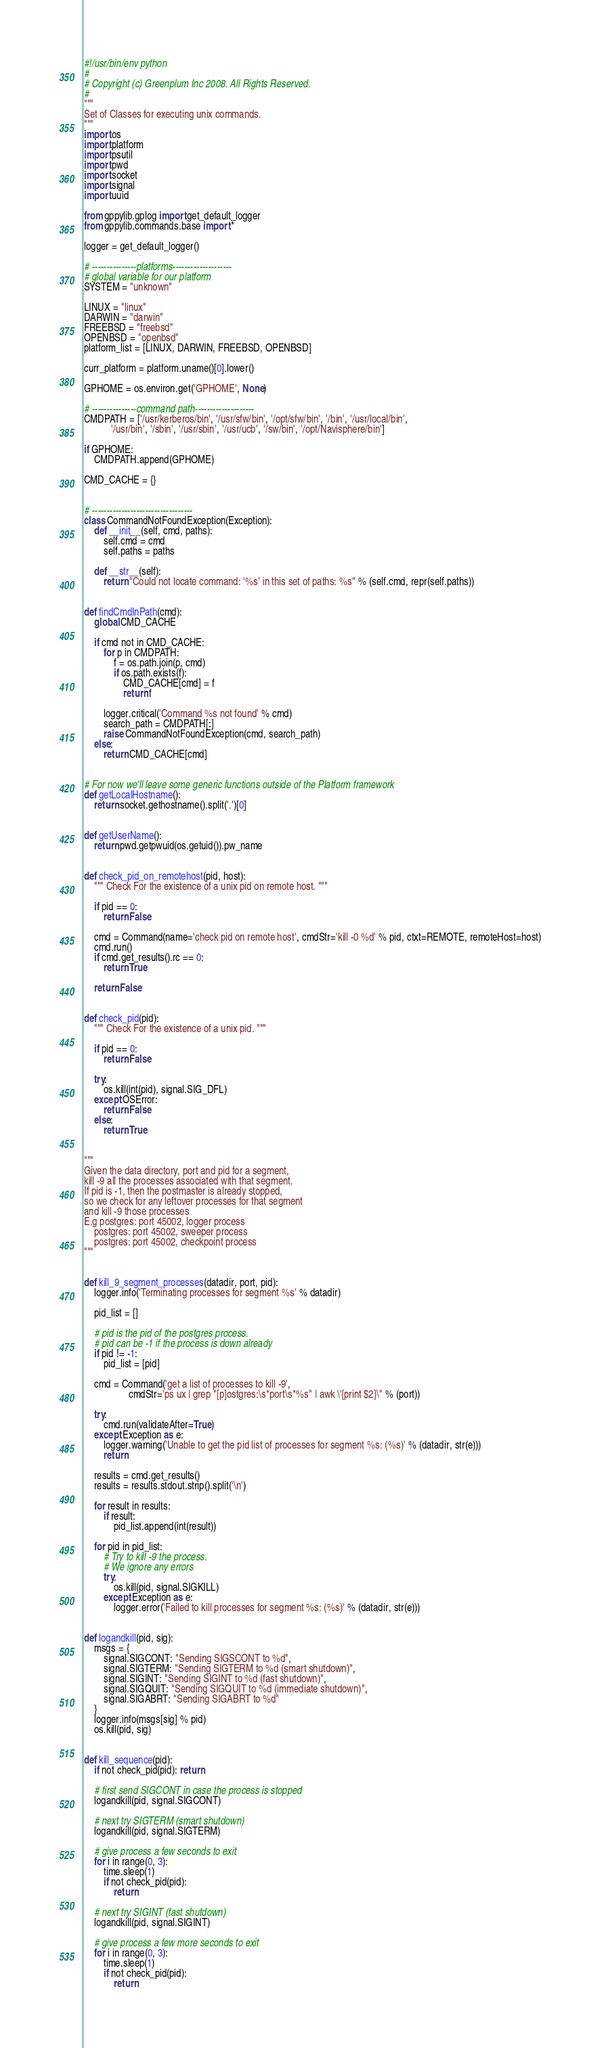<code> <loc_0><loc_0><loc_500><loc_500><_Python_>#!/usr/bin/env python
#
# Copyright (c) Greenplum Inc 2008. All Rights Reserved. 
#
"""
Set of Classes for executing unix commands.
"""
import os
import platform
import psutil
import pwd
import socket
import signal
import uuid

from gppylib.gplog import get_default_logger
from gppylib.commands.base import *

logger = get_default_logger()

# ---------------platforms--------------------
# global variable for our platform
SYSTEM = "unknown"

LINUX = "linux"
DARWIN = "darwin"
FREEBSD = "freebsd"
OPENBSD = "openbsd"
platform_list = [LINUX, DARWIN, FREEBSD, OPENBSD]

curr_platform = platform.uname()[0].lower()

GPHOME = os.environ.get('GPHOME', None)

# ---------------command path--------------------
CMDPATH = ['/usr/kerberos/bin', '/usr/sfw/bin', '/opt/sfw/bin', '/bin', '/usr/local/bin',
           '/usr/bin', '/sbin', '/usr/sbin', '/usr/ucb', '/sw/bin', '/opt/Navisphere/bin']

if GPHOME:
    CMDPATH.append(GPHOME)

CMD_CACHE = {}


# ----------------------------------
class CommandNotFoundException(Exception):
    def __init__(self, cmd, paths):
        self.cmd = cmd
        self.paths = paths

    def __str__(self):
        return "Could not locate command: '%s' in this set of paths: %s" % (self.cmd, repr(self.paths))


def findCmdInPath(cmd):
    global CMD_CACHE

    if cmd not in CMD_CACHE:
        for p in CMDPATH:
            f = os.path.join(p, cmd)
            if os.path.exists(f):
                CMD_CACHE[cmd] = f
                return f

        logger.critical('Command %s not found' % cmd)
        search_path = CMDPATH[:]
        raise CommandNotFoundException(cmd, search_path)
    else:
        return CMD_CACHE[cmd]


# For now we'll leave some generic functions outside of the Platform framework
def getLocalHostname():
    return socket.gethostname().split('.')[0]


def getUserName():
    return pwd.getpwuid(os.getuid()).pw_name


def check_pid_on_remotehost(pid, host):
    """ Check For the existence of a unix pid on remote host. """

    if pid == 0:
        return False

    cmd = Command(name='check pid on remote host', cmdStr='kill -0 %d' % pid, ctxt=REMOTE, remoteHost=host)
    cmd.run()
    if cmd.get_results().rc == 0:
        return True

    return False


def check_pid(pid):
    """ Check For the existence of a unix pid. """

    if pid == 0:
        return False

    try:
        os.kill(int(pid), signal.SIG_DFL)
    except OSError:
        return False
    else:
        return True


"""
Given the data directory, port and pid for a segment, 
kill -9 all the processes associated with that segment.
If pid is -1, then the postmaster is already stopped, 
so we check for any leftover processes for that segment 
and kill -9 those processes
E.g postgres: port 45002, logger process
    postgres: port 45002, sweeper process
    postgres: port 45002, checkpoint process
"""


def kill_9_segment_processes(datadir, port, pid):
    logger.info('Terminating processes for segment %s' % datadir)

    pid_list = []

    # pid is the pid of the postgres process.
    # pid can be -1 if the process is down already
    if pid != -1:
        pid_list = [pid]

    cmd = Command('get a list of processes to kill -9',
                  cmdStr='ps ux | grep "[p]ostgres:\s*port\s*%s" | awk \'{print $2}\'' % (port))

    try:
        cmd.run(validateAfter=True)
    except Exception as e:
        logger.warning('Unable to get the pid list of processes for segment %s: (%s)' % (datadir, str(e)))
        return

    results = cmd.get_results()
    results = results.stdout.strip().split('\n')

    for result in results:
        if result:
            pid_list.append(int(result))

    for pid in pid_list:
        # Try to kill -9 the process.
        # We ignore any errors 
        try:
            os.kill(pid, signal.SIGKILL)
        except Exception as e:
            logger.error('Failed to kill processes for segment %s: (%s)' % (datadir, str(e)))


def logandkill(pid, sig):
    msgs = {
        signal.SIGCONT: "Sending SIGSCONT to %d",
        signal.SIGTERM: "Sending SIGTERM to %d (smart shutdown)",
        signal.SIGINT: "Sending SIGINT to %d (fast shutdown)",
        signal.SIGQUIT: "Sending SIGQUIT to %d (immediate shutdown)",
        signal.SIGABRT: "Sending SIGABRT to %d"
    }
    logger.info(msgs[sig] % pid)
    os.kill(pid, sig)


def kill_sequence(pid):
    if not check_pid(pid): return

    # first send SIGCONT in case the process is stopped
    logandkill(pid, signal.SIGCONT)

    # next try SIGTERM (smart shutdown)
    logandkill(pid, signal.SIGTERM)

    # give process a few seconds to exit
    for i in range(0, 3):
        time.sleep(1)
        if not check_pid(pid):
            return

    # next try SIGINT (fast shutdown)
    logandkill(pid, signal.SIGINT)

    # give process a few more seconds to exit
    for i in range(0, 3):
        time.sleep(1)
        if not check_pid(pid):
            return
</code> 